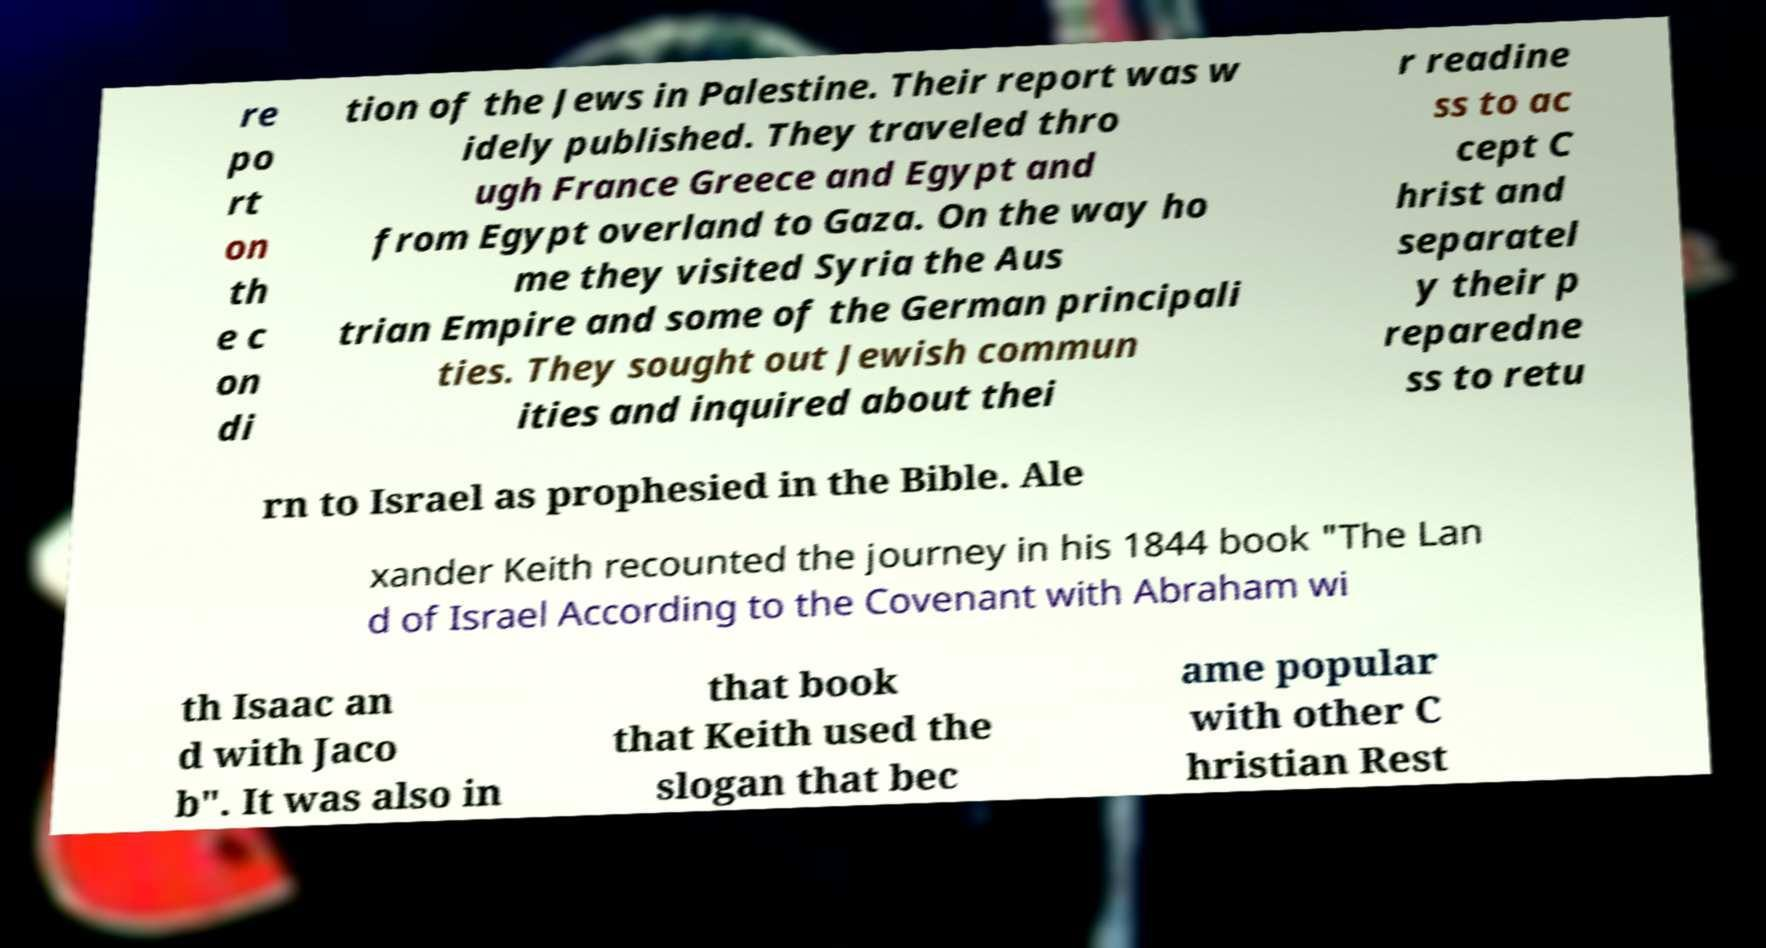I need the written content from this picture converted into text. Can you do that? re po rt on th e c on di tion of the Jews in Palestine. Their report was w idely published. They traveled thro ugh France Greece and Egypt and from Egypt overland to Gaza. On the way ho me they visited Syria the Aus trian Empire and some of the German principali ties. They sought out Jewish commun ities and inquired about thei r readine ss to ac cept C hrist and separatel y their p reparedne ss to retu rn to Israel as prophesied in the Bible. Ale xander Keith recounted the journey in his 1844 book "The Lan d of Israel According to the Covenant with Abraham wi th Isaac an d with Jaco b". It was also in that book that Keith used the slogan that bec ame popular with other C hristian Rest 